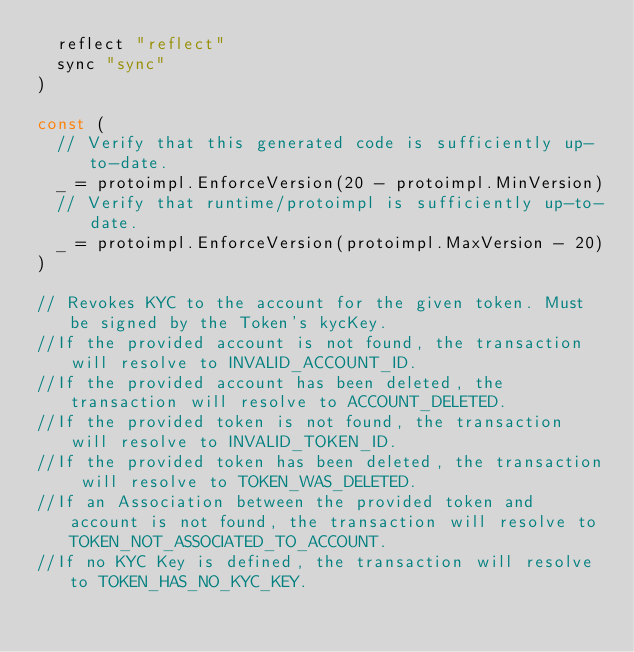Convert code to text. <code><loc_0><loc_0><loc_500><loc_500><_Go_>	reflect "reflect"
	sync "sync"
)

const (
	// Verify that this generated code is sufficiently up-to-date.
	_ = protoimpl.EnforceVersion(20 - protoimpl.MinVersion)
	// Verify that runtime/protoimpl is sufficiently up-to-date.
	_ = protoimpl.EnforceVersion(protoimpl.MaxVersion - 20)
)

// Revokes KYC to the account for the given token. Must be signed by the Token's kycKey.
//If the provided account is not found, the transaction will resolve to INVALID_ACCOUNT_ID.
//If the provided account has been deleted, the transaction will resolve to ACCOUNT_DELETED.
//If the provided token is not found, the transaction will resolve to INVALID_TOKEN_ID.
//If the provided token has been deleted, the transaction will resolve to TOKEN_WAS_DELETED.
//If an Association between the provided token and account is not found, the transaction will resolve to TOKEN_NOT_ASSOCIATED_TO_ACCOUNT.
//If no KYC Key is defined, the transaction will resolve to TOKEN_HAS_NO_KYC_KEY.</code> 